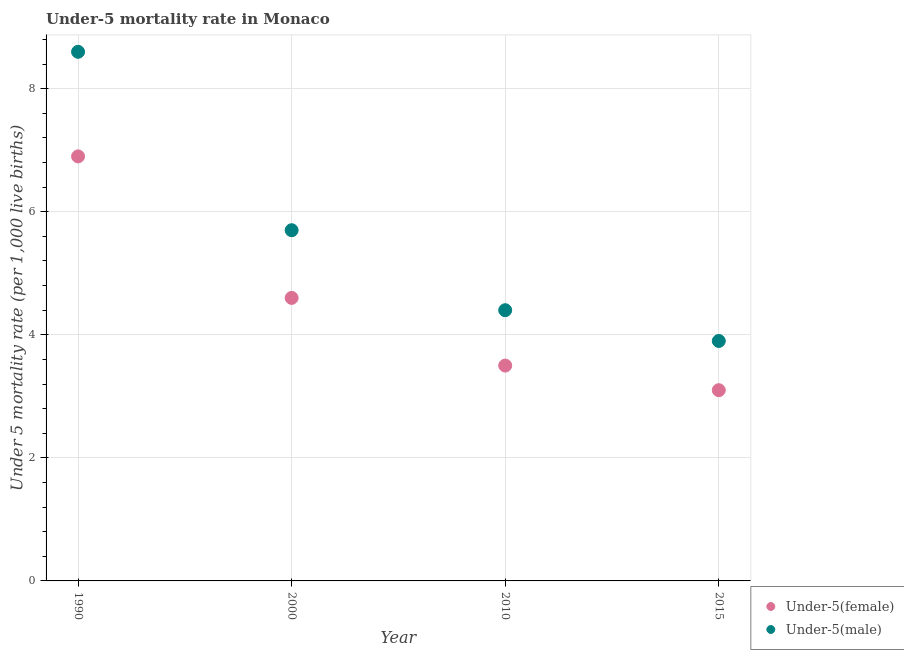In which year was the under-5 male mortality rate maximum?
Ensure brevity in your answer.  1990. In which year was the under-5 female mortality rate minimum?
Your answer should be compact. 2015. What is the total under-5 male mortality rate in the graph?
Make the answer very short. 22.6. What is the difference between the under-5 female mortality rate in 1990 and that in 2000?
Provide a succinct answer. 2.3. What is the difference between the under-5 female mortality rate in 2000 and the under-5 male mortality rate in 2015?
Keep it short and to the point. 0.7. What is the average under-5 female mortality rate per year?
Your response must be concise. 4.53. In the year 2015, what is the difference between the under-5 male mortality rate and under-5 female mortality rate?
Give a very brief answer. 0.8. What is the ratio of the under-5 male mortality rate in 1990 to that in 2010?
Your answer should be very brief. 1.95. Is the under-5 male mortality rate in 1990 less than that in 2010?
Make the answer very short. No. Is the difference between the under-5 female mortality rate in 2010 and 2015 greater than the difference between the under-5 male mortality rate in 2010 and 2015?
Offer a terse response. No. What is the difference between the highest and the second highest under-5 male mortality rate?
Make the answer very short. 2.9. What is the difference between the highest and the lowest under-5 male mortality rate?
Keep it short and to the point. 4.7. In how many years, is the under-5 female mortality rate greater than the average under-5 female mortality rate taken over all years?
Provide a short and direct response. 2. Does the under-5 female mortality rate monotonically increase over the years?
Your answer should be very brief. No. Is the under-5 male mortality rate strictly greater than the under-5 female mortality rate over the years?
Provide a short and direct response. Yes. How many dotlines are there?
Offer a very short reply. 2. How many years are there in the graph?
Make the answer very short. 4. Are the values on the major ticks of Y-axis written in scientific E-notation?
Your response must be concise. No. How many legend labels are there?
Ensure brevity in your answer.  2. What is the title of the graph?
Ensure brevity in your answer.  Under-5 mortality rate in Monaco. What is the label or title of the Y-axis?
Make the answer very short. Under 5 mortality rate (per 1,0 live births). What is the Under 5 mortality rate (per 1,000 live births) of Under-5(male) in 1990?
Your response must be concise. 8.6. What is the Under 5 mortality rate (per 1,000 live births) in Under-5(male) in 2000?
Offer a very short reply. 5.7. What is the Under 5 mortality rate (per 1,000 live births) in Under-5(male) in 2010?
Ensure brevity in your answer.  4.4. What is the Under 5 mortality rate (per 1,000 live births) in Under-5(female) in 2015?
Make the answer very short. 3.1. Across all years, what is the maximum Under 5 mortality rate (per 1,000 live births) in Under-5(female)?
Offer a very short reply. 6.9. Across all years, what is the maximum Under 5 mortality rate (per 1,000 live births) of Under-5(male)?
Provide a succinct answer. 8.6. Across all years, what is the minimum Under 5 mortality rate (per 1,000 live births) in Under-5(male)?
Keep it short and to the point. 3.9. What is the total Under 5 mortality rate (per 1,000 live births) in Under-5(male) in the graph?
Provide a succinct answer. 22.6. What is the difference between the Under 5 mortality rate (per 1,000 live births) of Under-5(female) in 1990 and that in 2010?
Offer a terse response. 3.4. What is the difference between the Under 5 mortality rate (per 1,000 live births) in Under-5(female) in 2000 and that in 2010?
Ensure brevity in your answer.  1.1. What is the difference between the Under 5 mortality rate (per 1,000 live births) in Under-5(female) in 2000 and that in 2015?
Offer a terse response. 1.5. What is the difference between the Under 5 mortality rate (per 1,000 live births) in Under-5(female) in 2000 and the Under 5 mortality rate (per 1,000 live births) in Under-5(male) in 2010?
Your answer should be compact. 0.2. What is the difference between the Under 5 mortality rate (per 1,000 live births) in Under-5(female) in 2000 and the Under 5 mortality rate (per 1,000 live births) in Under-5(male) in 2015?
Provide a short and direct response. 0.7. What is the average Under 5 mortality rate (per 1,000 live births) of Under-5(female) per year?
Provide a short and direct response. 4.53. What is the average Under 5 mortality rate (per 1,000 live births) of Under-5(male) per year?
Your response must be concise. 5.65. In the year 1990, what is the difference between the Under 5 mortality rate (per 1,000 live births) in Under-5(female) and Under 5 mortality rate (per 1,000 live births) in Under-5(male)?
Your response must be concise. -1.7. In the year 2000, what is the difference between the Under 5 mortality rate (per 1,000 live births) in Under-5(female) and Under 5 mortality rate (per 1,000 live births) in Under-5(male)?
Ensure brevity in your answer.  -1.1. In the year 2010, what is the difference between the Under 5 mortality rate (per 1,000 live births) of Under-5(female) and Under 5 mortality rate (per 1,000 live births) of Under-5(male)?
Your answer should be compact. -0.9. What is the ratio of the Under 5 mortality rate (per 1,000 live births) of Under-5(female) in 1990 to that in 2000?
Give a very brief answer. 1.5. What is the ratio of the Under 5 mortality rate (per 1,000 live births) of Under-5(male) in 1990 to that in 2000?
Provide a succinct answer. 1.51. What is the ratio of the Under 5 mortality rate (per 1,000 live births) of Under-5(female) in 1990 to that in 2010?
Your answer should be very brief. 1.97. What is the ratio of the Under 5 mortality rate (per 1,000 live births) in Under-5(male) in 1990 to that in 2010?
Offer a very short reply. 1.95. What is the ratio of the Under 5 mortality rate (per 1,000 live births) in Under-5(female) in 1990 to that in 2015?
Offer a very short reply. 2.23. What is the ratio of the Under 5 mortality rate (per 1,000 live births) of Under-5(male) in 1990 to that in 2015?
Keep it short and to the point. 2.21. What is the ratio of the Under 5 mortality rate (per 1,000 live births) of Under-5(female) in 2000 to that in 2010?
Make the answer very short. 1.31. What is the ratio of the Under 5 mortality rate (per 1,000 live births) of Under-5(male) in 2000 to that in 2010?
Provide a succinct answer. 1.3. What is the ratio of the Under 5 mortality rate (per 1,000 live births) in Under-5(female) in 2000 to that in 2015?
Offer a terse response. 1.48. What is the ratio of the Under 5 mortality rate (per 1,000 live births) of Under-5(male) in 2000 to that in 2015?
Your answer should be compact. 1.46. What is the ratio of the Under 5 mortality rate (per 1,000 live births) of Under-5(female) in 2010 to that in 2015?
Provide a succinct answer. 1.13. What is the ratio of the Under 5 mortality rate (per 1,000 live births) in Under-5(male) in 2010 to that in 2015?
Your response must be concise. 1.13. What is the difference between the highest and the second highest Under 5 mortality rate (per 1,000 live births) in Under-5(female)?
Your answer should be compact. 2.3. 